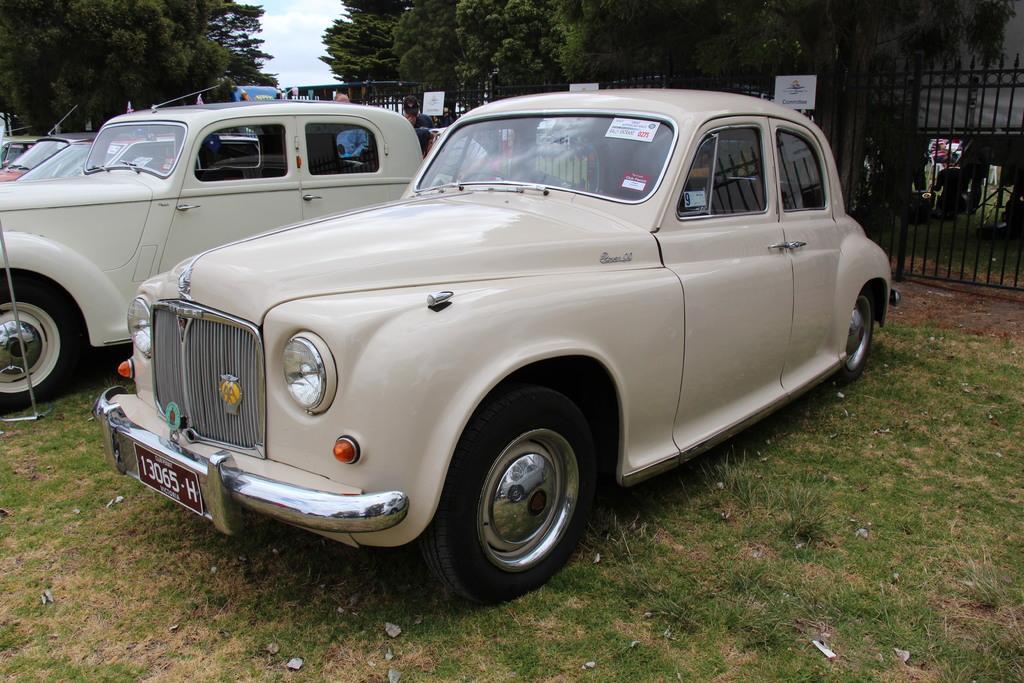How would you summarize this image in a sentence or two? In this picture I can see cars on the ground. In the background three fence, trees and the sky. Here I can see the grass. 